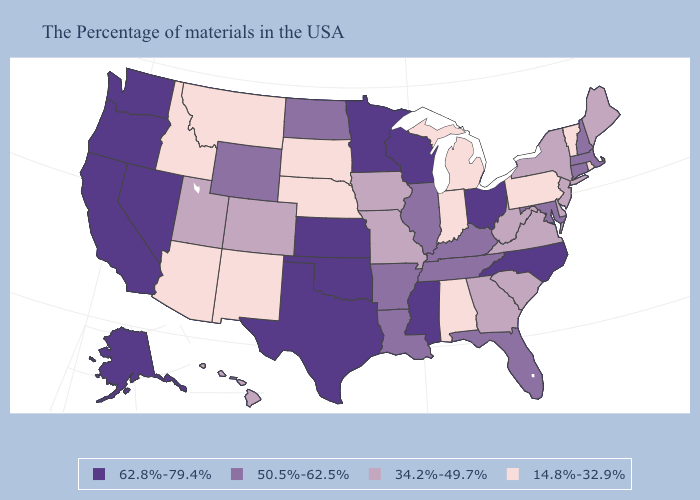Among the states that border Massachusetts , which have the lowest value?
Give a very brief answer. Rhode Island, Vermont. Does Iowa have the lowest value in the USA?
Concise answer only. No. What is the value of Nebraska?
Answer briefly. 14.8%-32.9%. Which states have the lowest value in the USA?
Be succinct. Rhode Island, Vermont, Pennsylvania, Michigan, Indiana, Alabama, Nebraska, South Dakota, New Mexico, Montana, Arizona, Idaho. Among the states that border Maryland , which have the highest value?
Quick response, please. Delaware, Virginia, West Virginia. Does California have the highest value in the West?
Give a very brief answer. Yes. Among the states that border Virginia , which have the lowest value?
Quick response, please. West Virginia. Which states hav the highest value in the MidWest?
Quick response, please. Ohio, Wisconsin, Minnesota, Kansas. What is the value of Arkansas?
Write a very short answer. 50.5%-62.5%. Does the first symbol in the legend represent the smallest category?
Give a very brief answer. No. Which states have the lowest value in the USA?
Quick response, please. Rhode Island, Vermont, Pennsylvania, Michigan, Indiana, Alabama, Nebraska, South Dakota, New Mexico, Montana, Arizona, Idaho. Among the states that border Oklahoma , which have the highest value?
Answer briefly. Kansas, Texas. What is the highest value in states that border Colorado?
Be succinct. 62.8%-79.4%. Does Texas have the lowest value in the USA?
Concise answer only. No. Name the states that have a value in the range 62.8%-79.4%?
Write a very short answer. North Carolina, Ohio, Wisconsin, Mississippi, Minnesota, Kansas, Oklahoma, Texas, Nevada, California, Washington, Oregon, Alaska. 